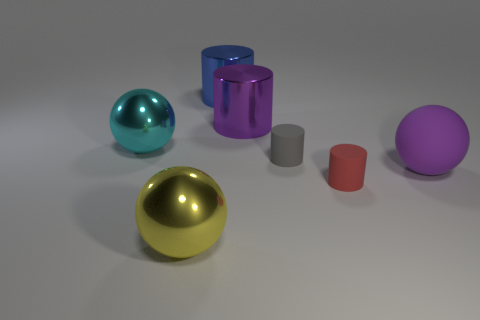Subtract all tiny gray matte cylinders. How many cylinders are left? 3 Subtract 2 cylinders. How many cylinders are left? 2 Subtract all blue cylinders. How many cylinders are left? 3 Add 1 big cylinders. How many objects exist? 8 Subtract all purple cylinders. Subtract all red blocks. How many cylinders are left? 3 Subtract all spheres. How many objects are left? 4 Add 3 large purple rubber spheres. How many large purple rubber spheres exist? 4 Subtract 0 yellow cubes. How many objects are left? 7 Subtract all big green shiny cylinders. Subtract all yellow things. How many objects are left? 6 Add 5 small gray things. How many small gray things are left? 6 